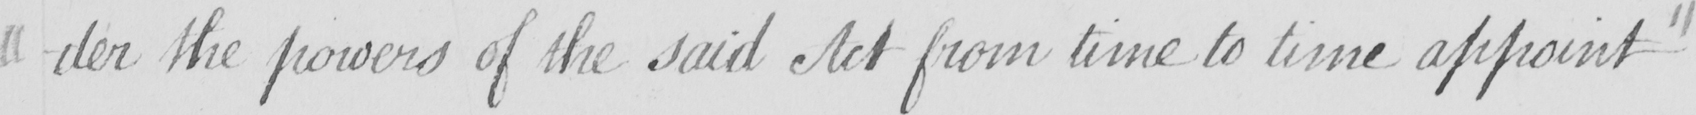Transcribe the text shown in this historical manuscript line. -der the powers of the said Act from time to time appoint  " 